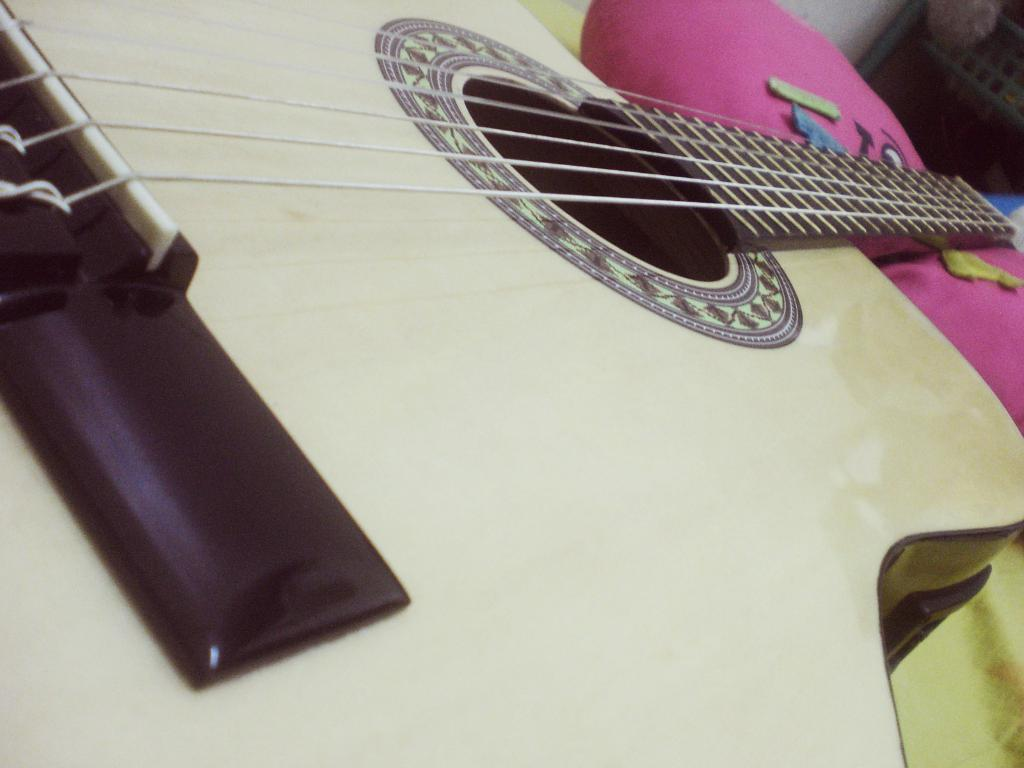What musical instrument is present in the image? There is a guitar in the image. What object is also visible in the image? There is a pillow in the image. What type of plant can be seen growing on the guitar in the image? There is no plant growing on the guitar in the image; it only features a guitar and a pillow. How does the wind affect the pillow in the image? There is no wind present in the image, and therefore no effect on the pillow can be observed. 